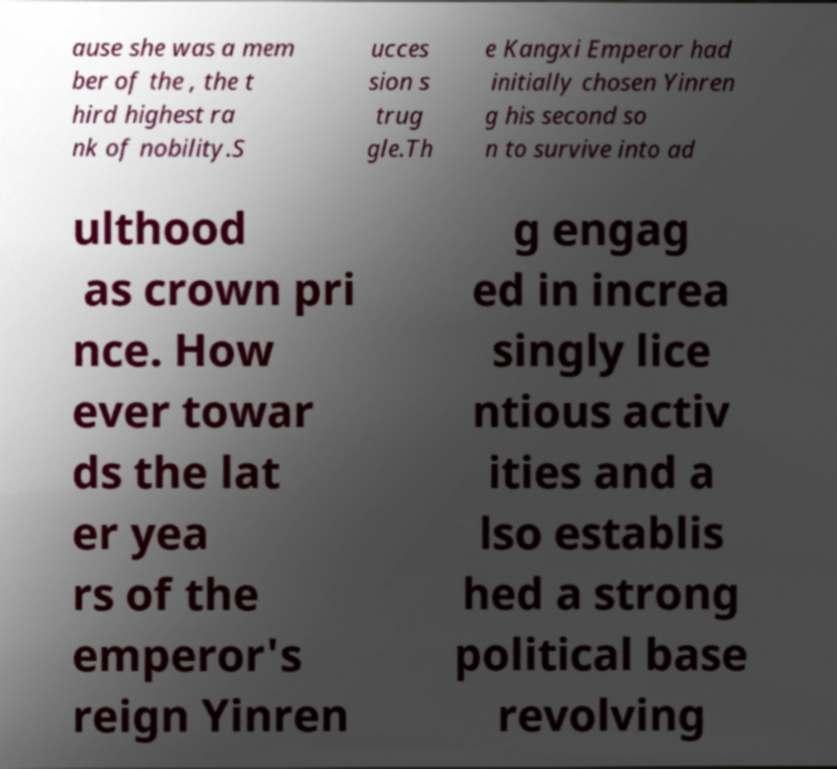Can you accurately transcribe the text from the provided image for me? ause she was a mem ber of the , the t hird highest ra nk of nobility.S ucces sion s trug gle.Th e Kangxi Emperor had initially chosen Yinren g his second so n to survive into ad ulthood as crown pri nce. How ever towar ds the lat er yea rs of the emperor's reign Yinren g engag ed in increa singly lice ntious activ ities and a lso establis hed a strong political base revolving 